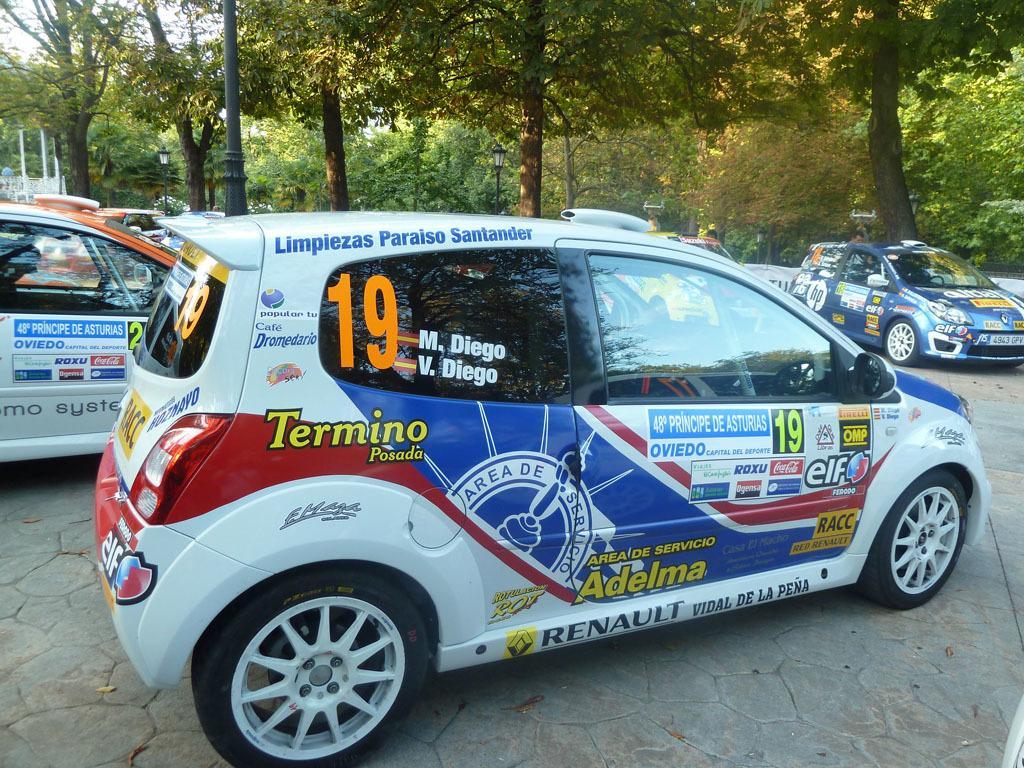How would you summarize this image in a sentence or two? In this image there are cars with some text and numbers written on it and there are trees. On the left side there are are poles which are white in colour and in the center there is a pole which is black in colour. 